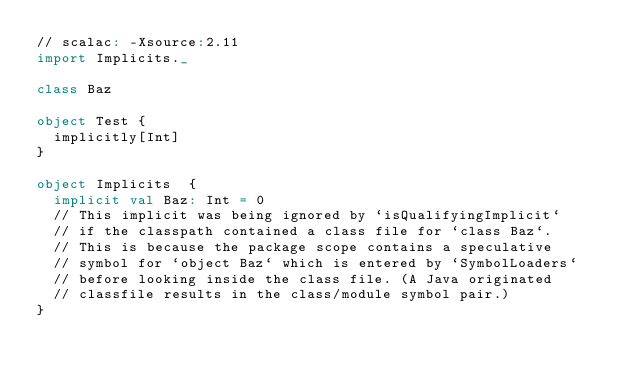<code> <loc_0><loc_0><loc_500><loc_500><_Scala_>// scalac: -Xsource:2.11
import Implicits._

class Baz

object Test {
  implicitly[Int]
}

object Implicits  {
  implicit val Baz: Int = 0
  // This implicit was being ignored by `isQualifyingImplicit`
  // if the classpath contained a class file for `class Baz`.
  // This is because the package scope contains a speculative
  // symbol for `object Baz` which is entered by `SymbolLoaders`
  // before looking inside the class file. (A Java originated
  // classfile results in the class/module symbol pair.)
}
</code> 